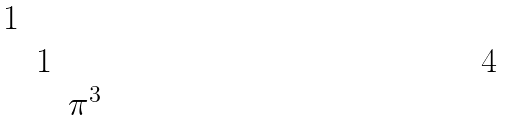<formula> <loc_0><loc_0><loc_500><loc_500>\begin{matrix} 1 & & \\ & 1 & \\ & & \pi ^ { 3 } \end{matrix}</formula> 